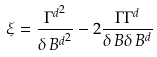Convert formula to latex. <formula><loc_0><loc_0><loc_500><loc_500>\xi = \frac { { \Gamma ^ { d } } ^ { 2 } } { { \delta \, B ^ { d } } ^ { 2 } } - 2 \frac { \Gamma \Gamma ^ { d } } { \delta \, B \delta \, B ^ { d } }</formula> 